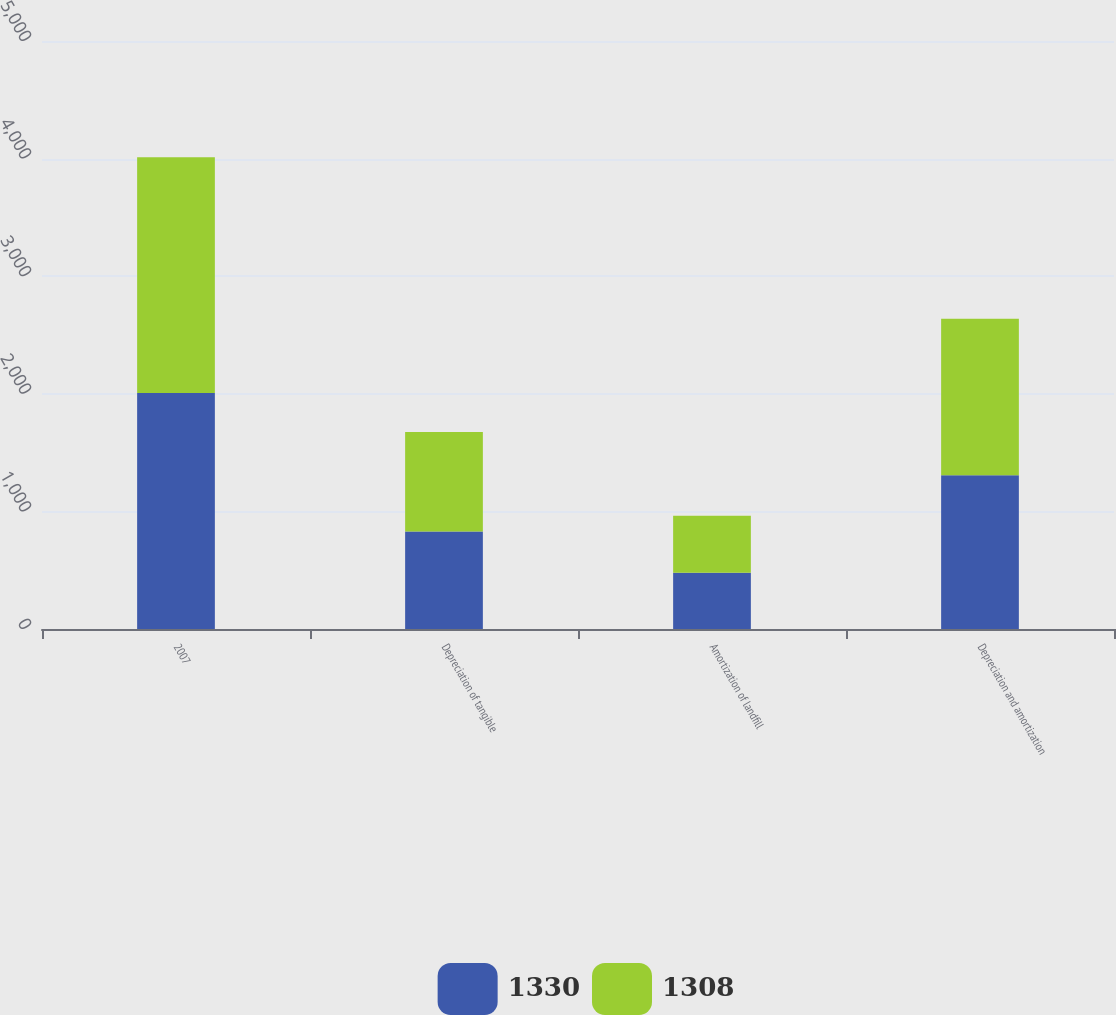Convert chart to OTSL. <chart><loc_0><loc_0><loc_500><loc_500><stacked_bar_chart><ecel><fcel>2007<fcel>Depreciation of tangible<fcel>Amortization of landfill<fcel>Depreciation and amortization<nl><fcel>1330<fcel>2006<fcel>829<fcel>479<fcel>1308<nl><fcel>1308<fcel>2005<fcel>847<fcel>483<fcel>1330<nl></chart> 